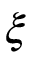<formula> <loc_0><loc_0><loc_500><loc_500>\xi</formula> 